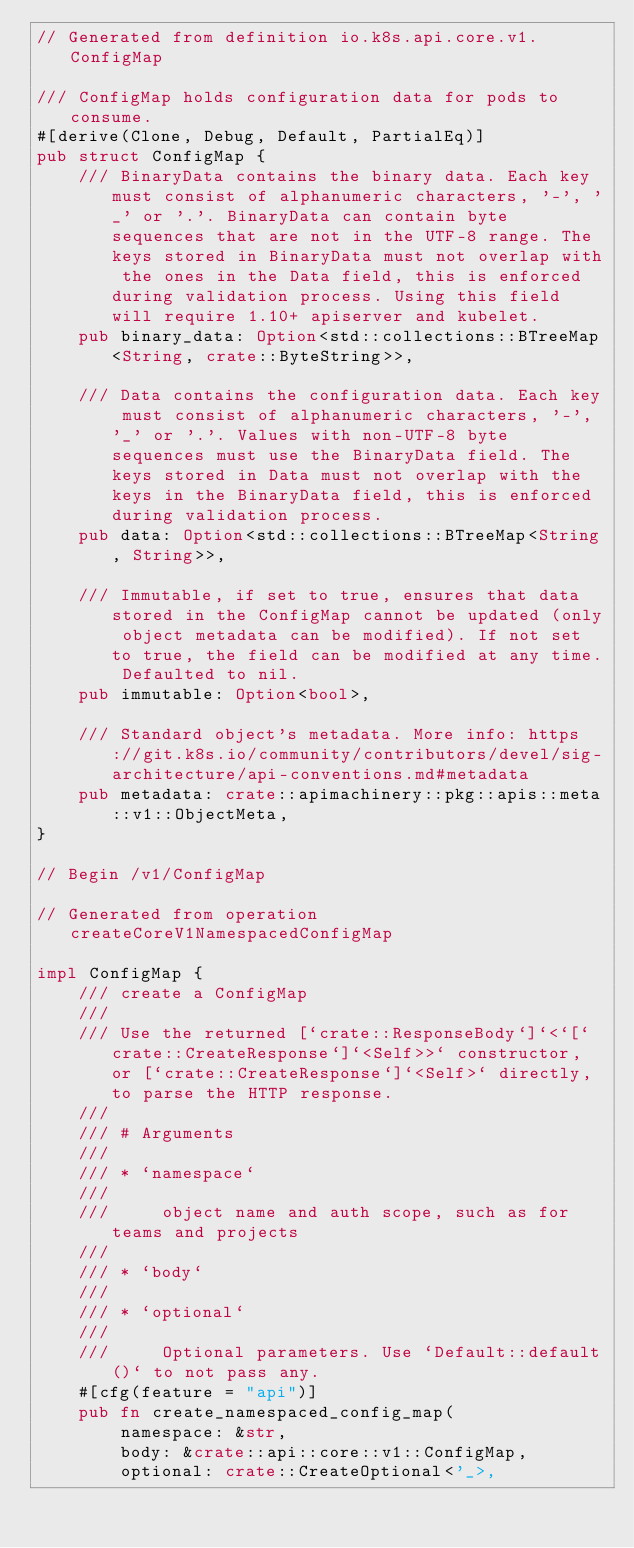Convert code to text. <code><loc_0><loc_0><loc_500><loc_500><_Rust_>// Generated from definition io.k8s.api.core.v1.ConfigMap

/// ConfigMap holds configuration data for pods to consume.
#[derive(Clone, Debug, Default, PartialEq)]
pub struct ConfigMap {
    /// BinaryData contains the binary data. Each key must consist of alphanumeric characters, '-', '_' or '.'. BinaryData can contain byte sequences that are not in the UTF-8 range. The keys stored in BinaryData must not overlap with the ones in the Data field, this is enforced during validation process. Using this field will require 1.10+ apiserver and kubelet.
    pub binary_data: Option<std::collections::BTreeMap<String, crate::ByteString>>,

    /// Data contains the configuration data. Each key must consist of alphanumeric characters, '-', '_' or '.'. Values with non-UTF-8 byte sequences must use the BinaryData field. The keys stored in Data must not overlap with the keys in the BinaryData field, this is enforced during validation process.
    pub data: Option<std::collections::BTreeMap<String, String>>,

    /// Immutable, if set to true, ensures that data stored in the ConfigMap cannot be updated (only object metadata can be modified). If not set to true, the field can be modified at any time. Defaulted to nil.
    pub immutable: Option<bool>,

    /// Standard object's metadata. More info: https://git.k8s.io/community/contributors/devel/sig-architecture/api-conventions.md#metadata
    pub metadata: crate::apimachinery::pkg::apis::meta::v1::ObjectMeta,
}

// Begin /v1/ConfigMap

// Generated from operation createCoreV1NamespacedConfigMap

impl ConfigMap {
    /// create a ConfigMap
    ///
    /// Use the returned [`crate::ResponseBody`]`<`[`crate::CreateResponse`]`<Self>>` constructor, or [`crate::CreateResponse`]`<Self>` directly, to parse the HTTP response.
    ///
    /// # Arguments
    ///
    /// * `namespace`
    ///
    ///     object name and auth scope, such as for teams and projects
    ///
    /// * `body`
    ///
    /// * `optional`
    ///
    ///     Optional parameters. Use `Default::default()` to not pass any.
    #[cfg(feature = "api")]
    pub fn create_namespaced_config_map(
        namespace: &str,
        body: &crate::api::core::v1::ConfigMap,
        optional: crate::CreateOptional<'_>,</code> 